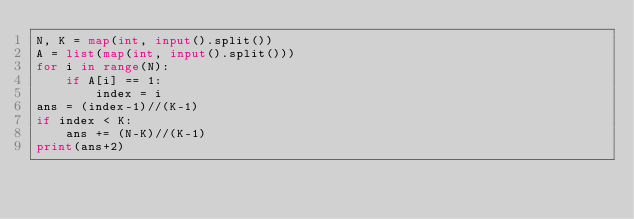Convert code to text. <code><loc_0><loc_0><loc_500><loc_500><_Python_>N, K = map(int, input().split())
A = list(map(int, input().split()))
for i in range(N):
    if A[i] == 1:
        index = i
ans = (index-1)//(K-1)
if index < K:
    ans += (N-K)//(K-1)
print(ans+2)
</code> 